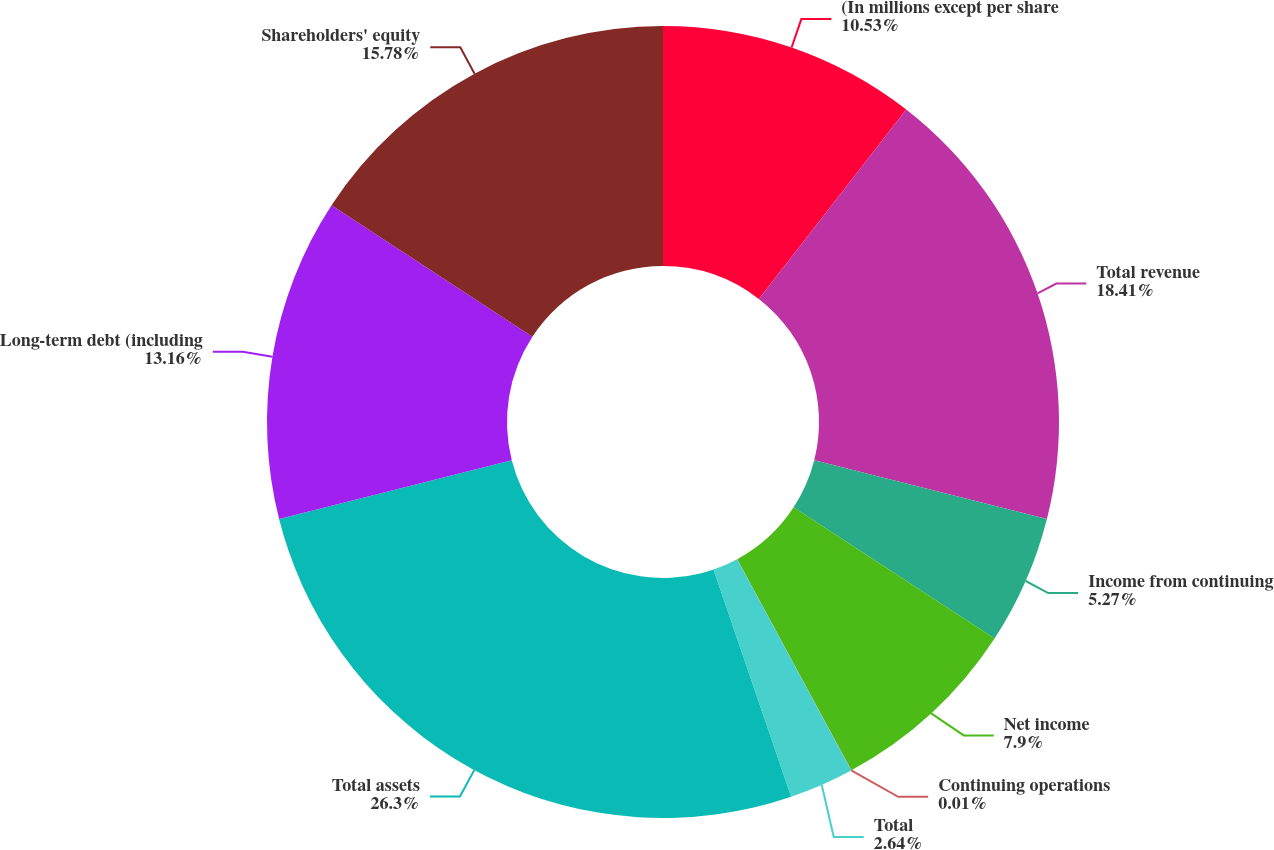Convert chart to OTSL. <chart><loc_0><loc_0><loc_500><loc_500><pie_chart><fcel>(In millions except per share<fcel>Total revenue<fcel>Income from continuing<fcel>Net income<fcel>Continuing operations<fcel>Total<fcel>Total assets<fcel>Long-term debt (including<fcel>Shareholders' equity<nl><fcel>10.53%<fcel>18.42%<fcel>5.27%<fcel>7.9%<fcel>0.01%<fcel>2.64%<fcel>26.31%<fcel>13.16%<fcel>15.79%<nl></chart> 